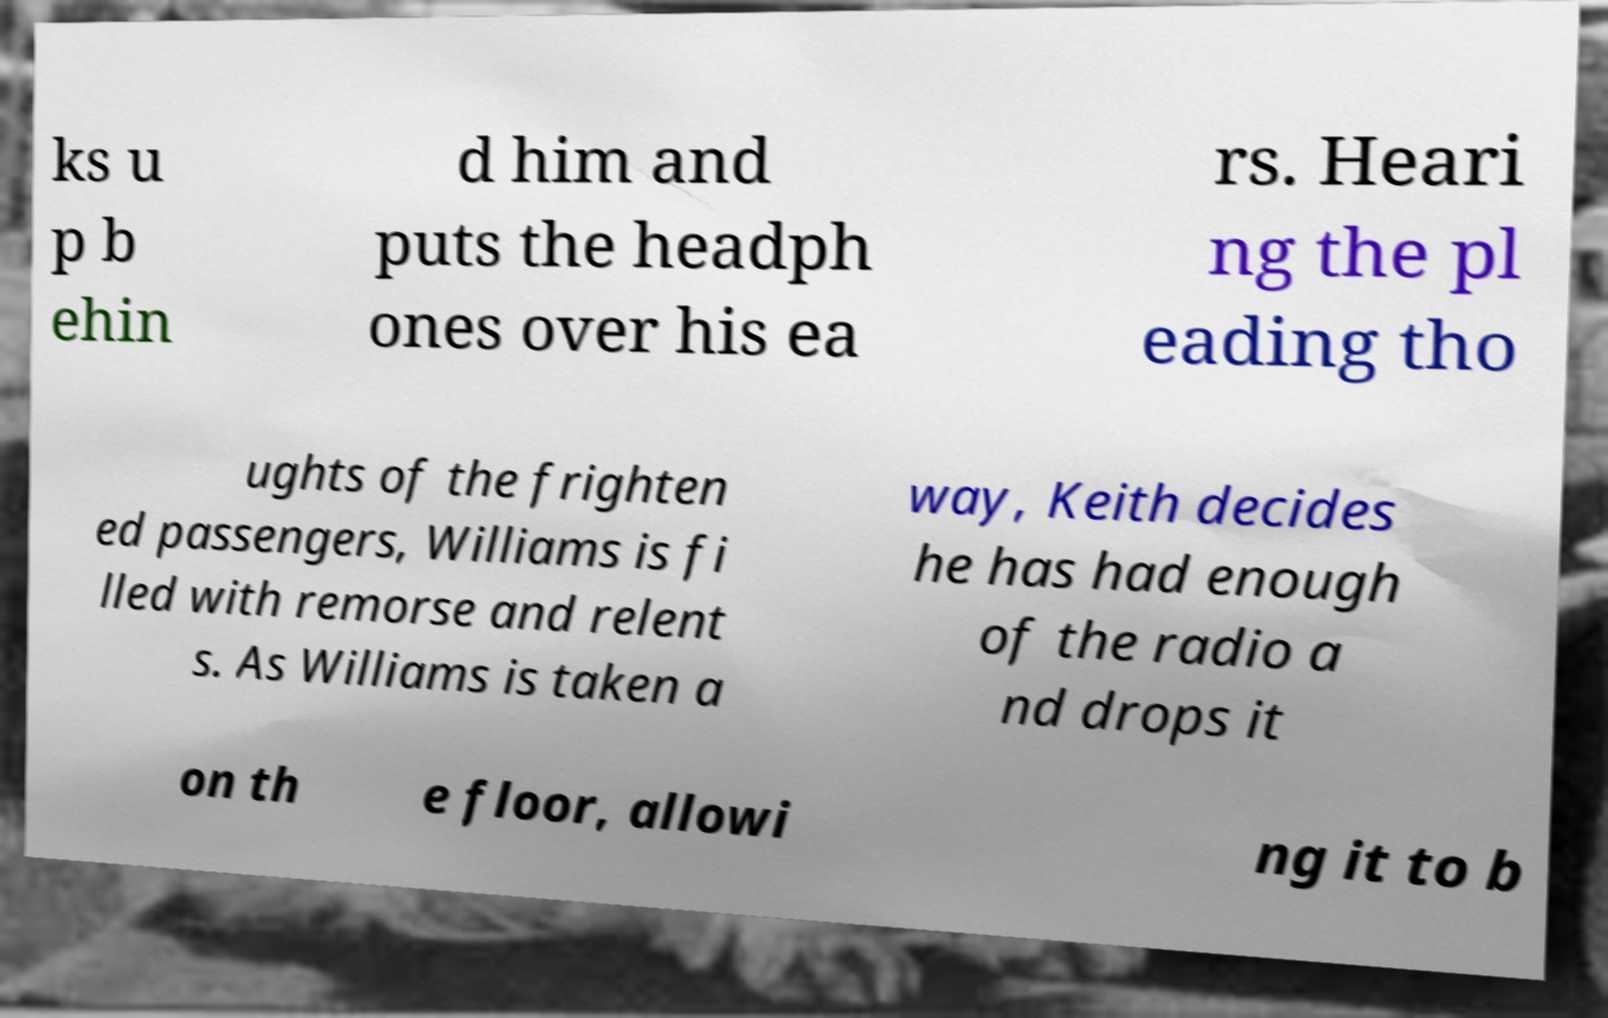For documentation purposes, I need the text within this image transcribed. Could you provide that? ks u p b ehin d him and puts the headph ones over his ea rs. Heari ng the pl eading tho ughts of the frighten ed passengers, Williams is fi lled with remorse and relent s. As Williams is taken a way, Keith decides he has had enough of the radio a nd drops it on th e floor, allowi ng it to b 